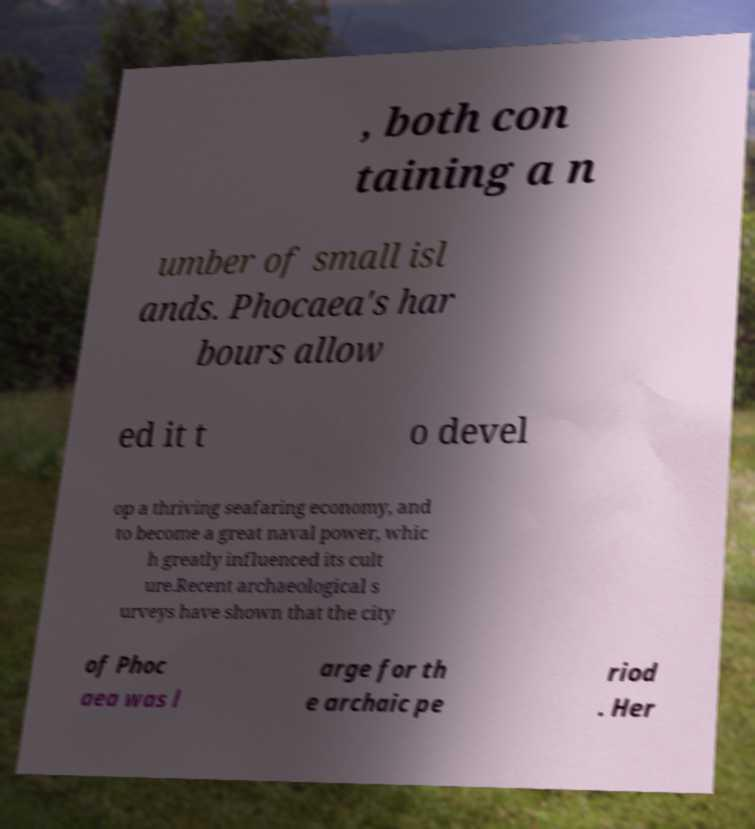Please identify and transcribe the text found in this image. , both con taining a n umber of small isl ands. Phocaea's har bours allow ed it t o devel op a thriving seafaring economy, and to become a great naval power, whic h greatly influenced its cult ure.Recent archaeological s urveys have shown that the city of Phoc aea was l arge for th e archaic pe riod . Her 